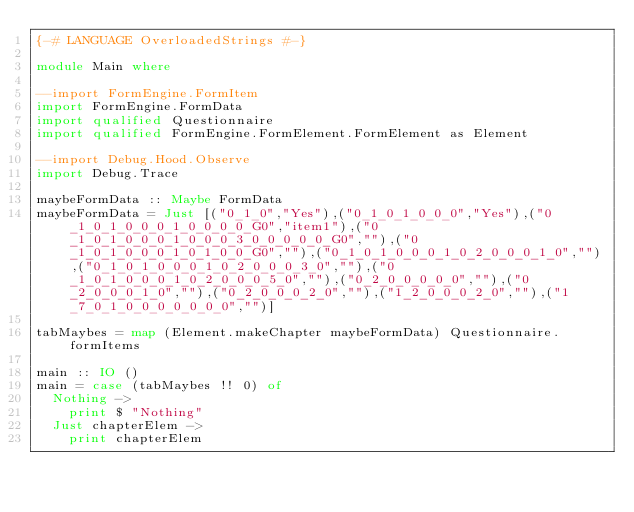<code> <loc_0><loc_0><loc_500><loc_500><_Haskell_>{-# LANGUAGE OverloadedStrings #-}

module Main where

--import FormEngine.FormItem
import FormEngine.FormData
import qualified Questionnaire
import qualified FormEngine.FormElement.FormElement as Element

--import Debug.Hood.Observe
import Debug.Trace

maybeFormData :: Maybe FormData
maybeFormData = Just [("0_1_0","Yes"),("0_1_0_1_0_0_0","Yes"),("0_1_0_1_0_0_0_1_0_0_0_0_G0","item1"),("0_1_0_1_0_0_0_1_0_0_0_3_0_0_0_0_0_G0",""),("0_1_0_1_0_0_0_1_0_1_0_0_G0",""),("0_1_0_1_0_0_0_1_0_2_0_0_0_1_0",""),("0_1_0_1_0_0_0_1_0_2_0_0_0_3_0",""),("0_1_0_1_0_0_0_1_0_2_0_0_0_5_0",""),("0_2_0_0_0_0_0",""),("0_2_0_0_0_1_0",""),("0_2_0_0_0_2_0",""),("1_2_0_0_0_2_0",""),("1_7_0_1_0_0_0_0_0_0_0","")]

tabMaybes = map (Element.makeChapter maybeFormData) Questionnaire.formItems

main :: IO ()
main = case (tabMaybes !! 0) of
  Nothing ->
    print $ "Nothing"
  Just chapterElem ->
    print chapterElem




</code> 